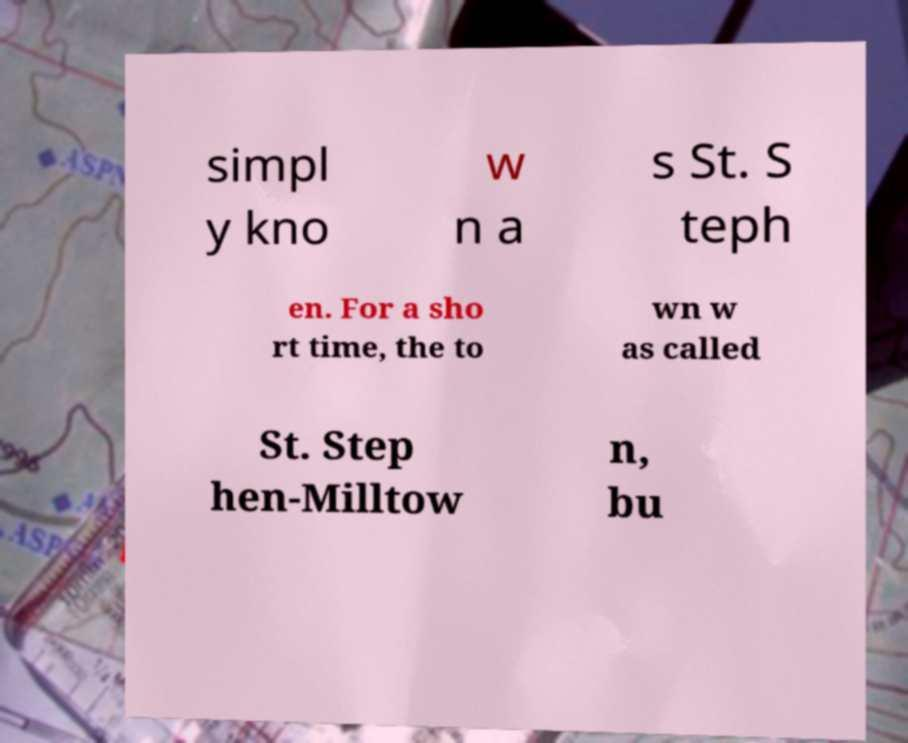For documentation purposes, I need the text within this image transcribed. Could you provide that? simpl y kno w n a s St. S teph en. For a sho rt time, the to wn w as called St. Step hen-Milltow n, bu 